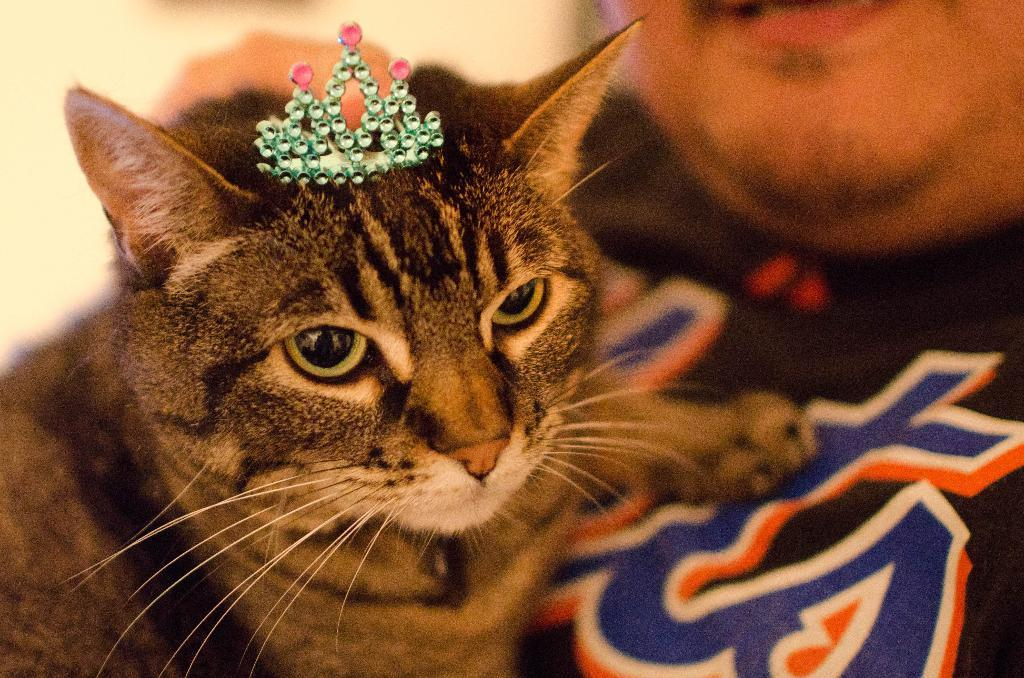What is the main subject of the image? There is a person in the image. What is the person holding in the image? The person is holding a cat. What can be seen in the background of the image? There is a wall in the background of the image. What type of jail can be seen in the image? There is no jail present in the image; it features a person holding a cat with a wall in the background. What is the cause of death for the person in the image? There is no indication of death in the image; the person is holding a cat. 